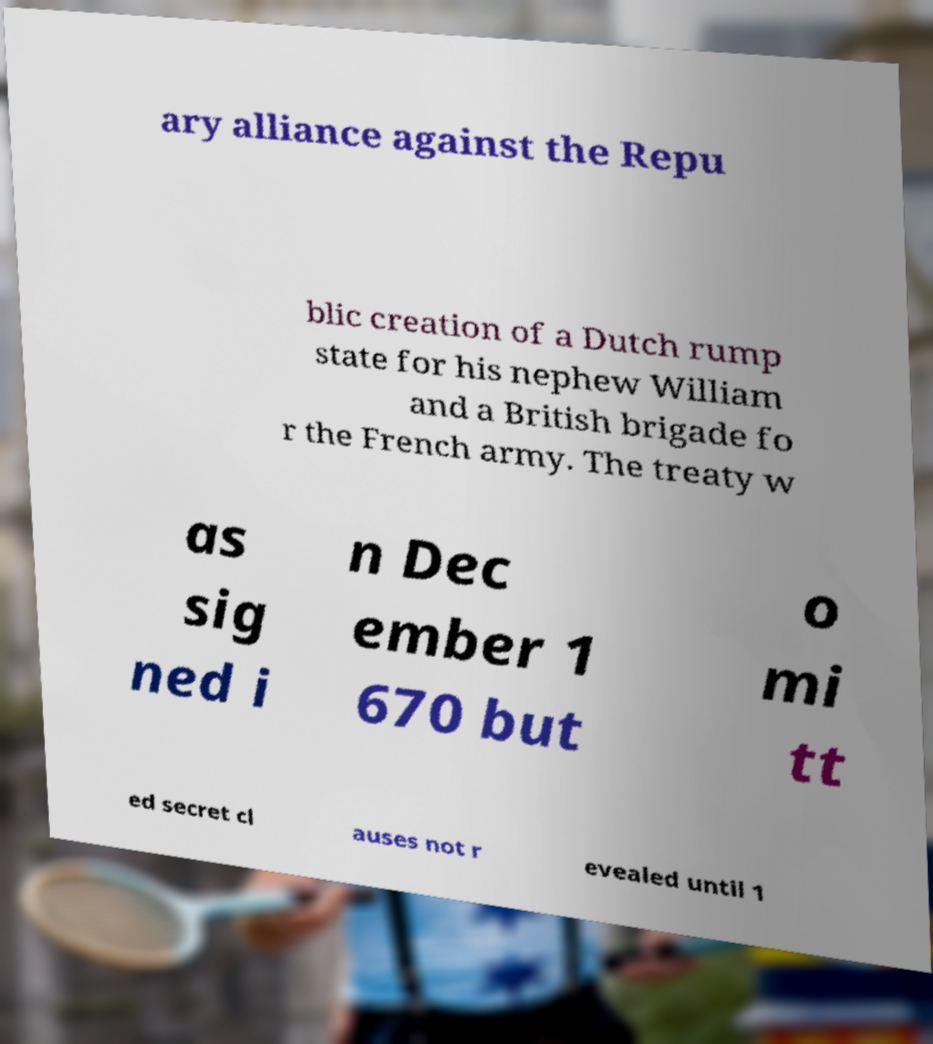Can you read and provide the text displayed in the image?This photo seems to have some interesting text. Can you extract and type it out for me? ary alliance against the Repu blic creation of a Dutch rump state for his nephew William and a British brigade fo r the French army. The treaty w as sig ned i n Dec ember 1 670 but o mi tt ed secret cl auses not r evealed until 1 